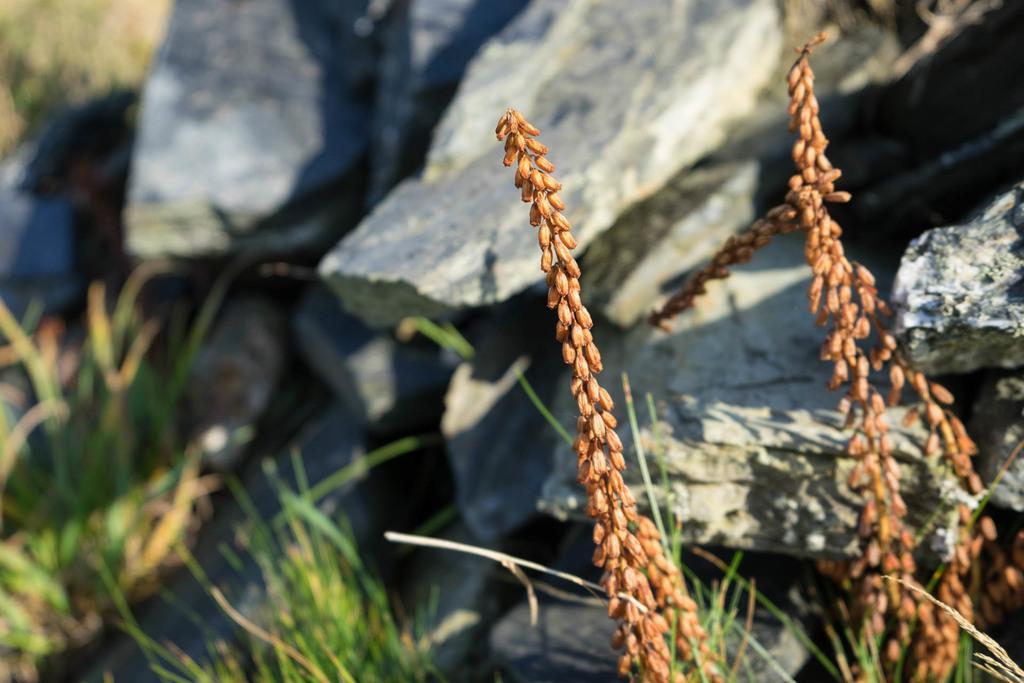Could you give a brief overview of what you see in this image? In this image we can see some rocks, some grass on the ground, one object on the rock on the top right side of the image, it looks like few plants stems with buds on the bottom right side of the image and the background is blurred. 